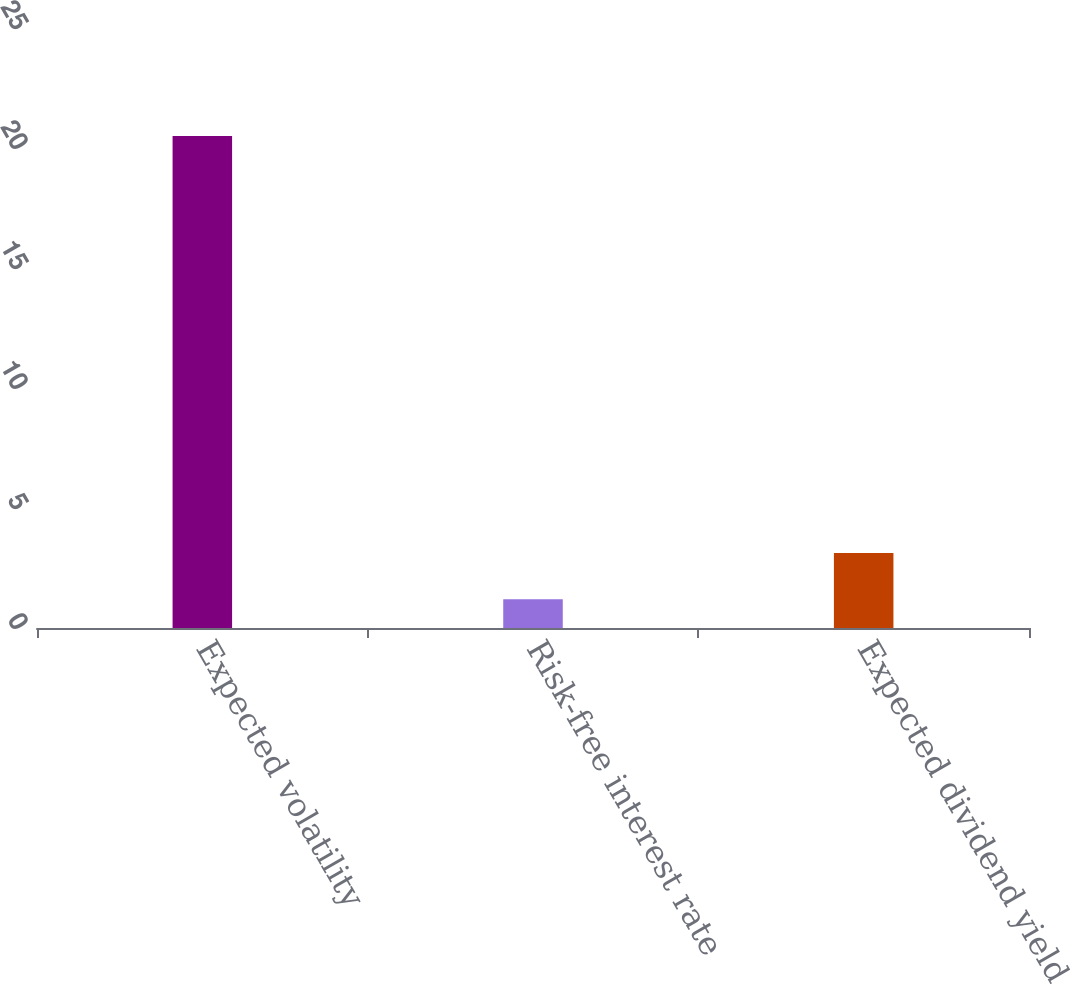<chart> <loc_0><loc_0><loc_500><loc_500><bar_chart><fcel>Expected volatility<fcel>Risk-free interest rate<fcel>Expected dividend yield<nl><fcel>20.5<fcel>1.2<fcel>3.13<nl></chart> 